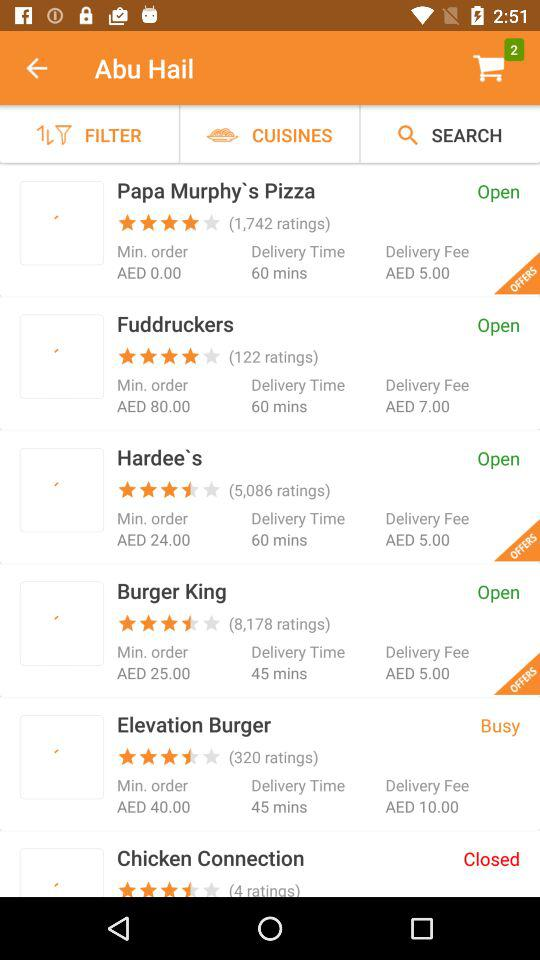What is the status of "Papa Murphy's Pizza"? The status is "Open". 